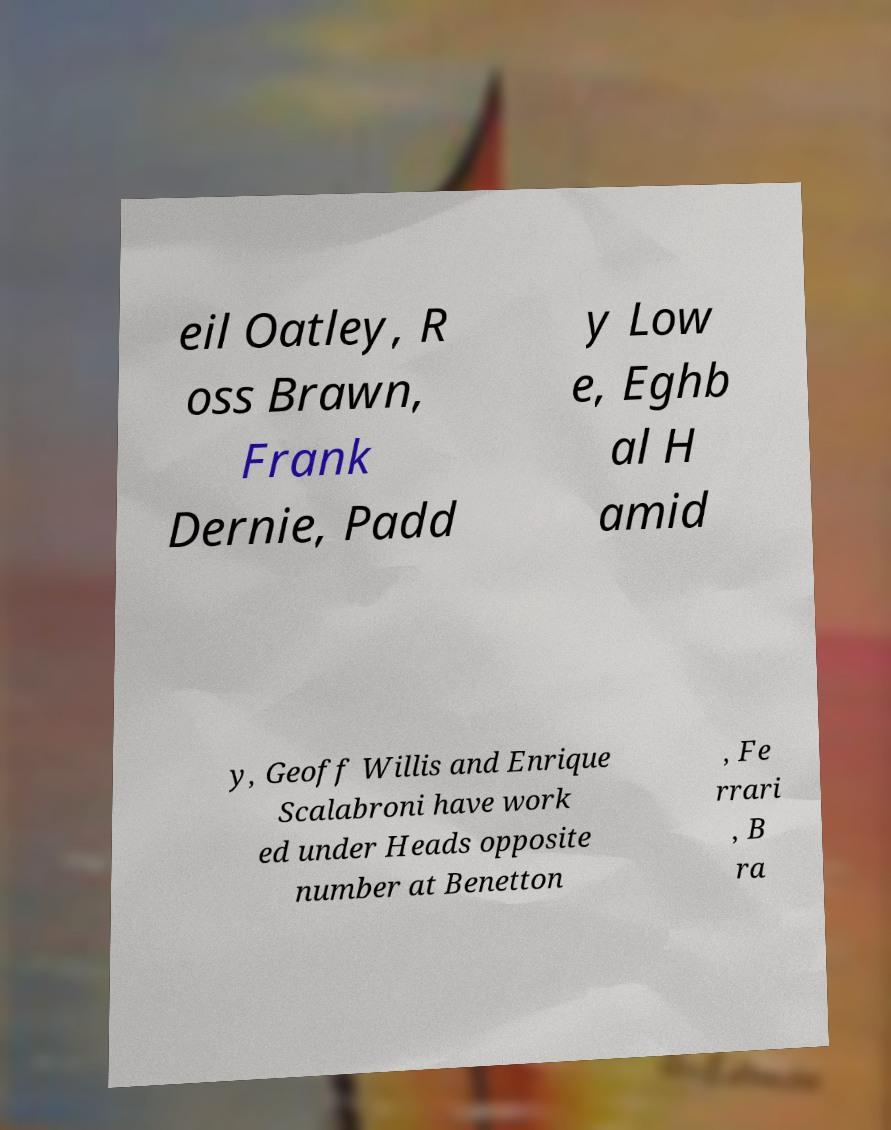Please read and relay the text visible in this image. What does it say? eil Oatley, R oss Brawn, Frank Dernie, Padd y Low e, Eghb al H amid y, Geoff Willis and Enrique Scalabroni have work ed under Heads opposite number at Benetton , Fe rrari , B ra 